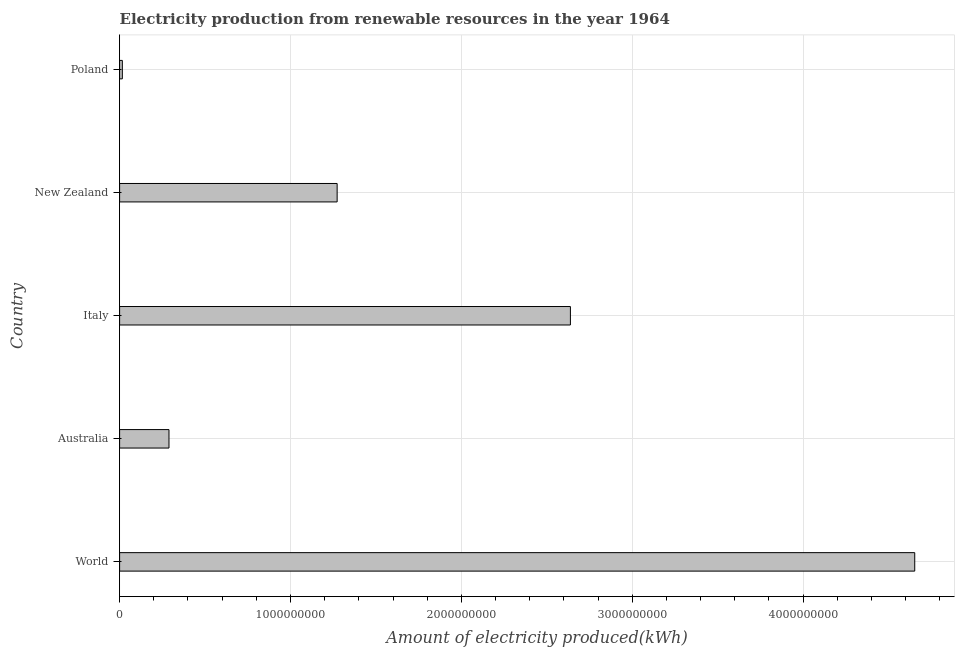What is the title of the graph?
Your answer should be very brief. Electricity production from renewable resources in the year 1964. What is the label or title of the X-axis?
Your answer should be very brief. Amount of electricity produced(kWh). What is the label or title of the Y-axis?
Your response must be concise. Country. What is the amount of electricity produced in World?
Provide a succinct answer. 4.65e+09. Across all countries, what is the maximum amount of electricity produced?
Give a very brief answer. 4.65e+09. Across all countries, what is the minimum amount of electricity produced?
Make the answer very short. 1.60e+07. In which country was the amount of electricity produced minimum?
Your answer should be compact. Poland. What is the sum of the amount of electricity produced?
Give a very brief answer. 8.87e+09. What is the difference between the amount of electricity produced in Italy and New Zealand?
Offer a very short reply. 1.36e+09. What is the average amount of electricity produced per country?
Offer a very short reply. 1.77e+09. What is the median amount of electricity produced?
Your answer should be very brief. 1.27e+09. In how many countries, is the amount of electricity produced greater than 3200000000 kWh?
Your response must be concise. 1. What is the ratio of the amount of electricity produced in Australia to that in Poland?
Offer a terse response. 18.06. Is the amount of electricity produced in Australia less than that in Poland?
Make the answer very short. No. What is the difference between the highest and the second highest amount of electricity produced?
Your answer should be compact. 2.02e+09. Is the sum of the amount of electricity produced in Italy and Poland greater than the maximum amount of electricity produced across all countries?
Provide a short and direct response. No. What is the difference between the highest and the lowest amount of electricity produced?
Provide a succinct answer. 4.64e+09. How many bars are there?
Offer a very short reply. 5. Are all the bars in the graph horizontal?
Offer a very short reply. Yes. How many countries are there in the graph?
Your response must be concise. 5. What is the difference between two consecutive major ticks on the X-axis?
Provide a short and direct response. 1.00e+09. What is the Amount of electricity produced(kWh) of World?
Offer a terse response. 4.65e+09. What is the Amount of electricity produced(kWh) in Australia?
Offer a very short reply. 2.89e+08. What is the Amount of electricity produced(kWh) in Italy?
Provide a short and direct response. 2.64e+09. What is the Amount of electricity produced(kWh) of New Zealand?
Provide a succinct answer. 1.27e+09. What is the Amount of electricity produced(kWh) in Poland?
Your answer should be compact. 1.60e+07. What is the difference between the Amount of electricity produced(kWh) in World and Australia?
Your answer should be compact. 4.36e+09. What is the difference between the Amount of electricity produced(kWh) in World and Italy?
Give a very brief answer. 2.02e+09. What is the difference between the Amount of electricity produced(kWh) in World and New Zealand?
Keep it short and to the point. 3.38e+09. What is the difference between the Amount of electricity produced(kWh) in World and Poland?
Give a very brief answer. 4.64e+09. What is the difference between the Amount of electricity produced(kWh) in Australia and Italy?
Your answer should be very brief. -2.35e+09. What is the difference between the Amount of electricity produced(kWh) in Australia and New Zealand?
Provide a succinct answer. -9.84e+08. What is the difference between the Amount of electricity produced(kWh) in Australia and Poland?
Make the answer very short. 2.73e+08. What is the difference between the Amount of electricity produced(kWh) in Italy and New Zealand?
Offer a terse response. 1.36e+09. What is the difference between the Amount of electricity produced(kWh) in Italy and Poland?
Your answer should be very brief. 2.62e+09. What is the difference between the Amount of electricity produced(kWh) in New Zealand and Poland?
Provide a short and direct response. 1.26e+09. What is the ratio of the Amount of electricity produced(kWh) in World to that in Italy?
Ensure brevity in your answer.  1.76. What is the ratio of the Amount of electricity produced(kWh) in World to that in New Zealand?
Offer a very short reply. 3.65. What is the ratio of the Amount of electricity produced(kWh) in World to that in Poland?
Your response must be concise. 290.81. What is the ratio of the Amount of electricity produced(kWh) in Australia to that in Italy?
Your response must be concise. 0.11. What is the ratio of the Amount of electricity produced(kWh) in Australia to that in New Zealand?
Provide a short and direct response. 0.23. What is the ratio of the Amount of electricity produced(kWh) in Australia to that in Poland?
Provide a short and direct response. 18.06. What is the ratio of the Amount of electricity produced(kWh) in Italy to that in New Zealand?
Offer a very short reply. 2.07. What is the ratio of the Amount of electricity produced(kWh) in Italy to that in Poland?
Your answer should be very brief. 164.88. What is the ratio of the Amount of electricity produced(kWh) in New Zealand to that in Poland?
Keep it short and to the point. 79.56. 